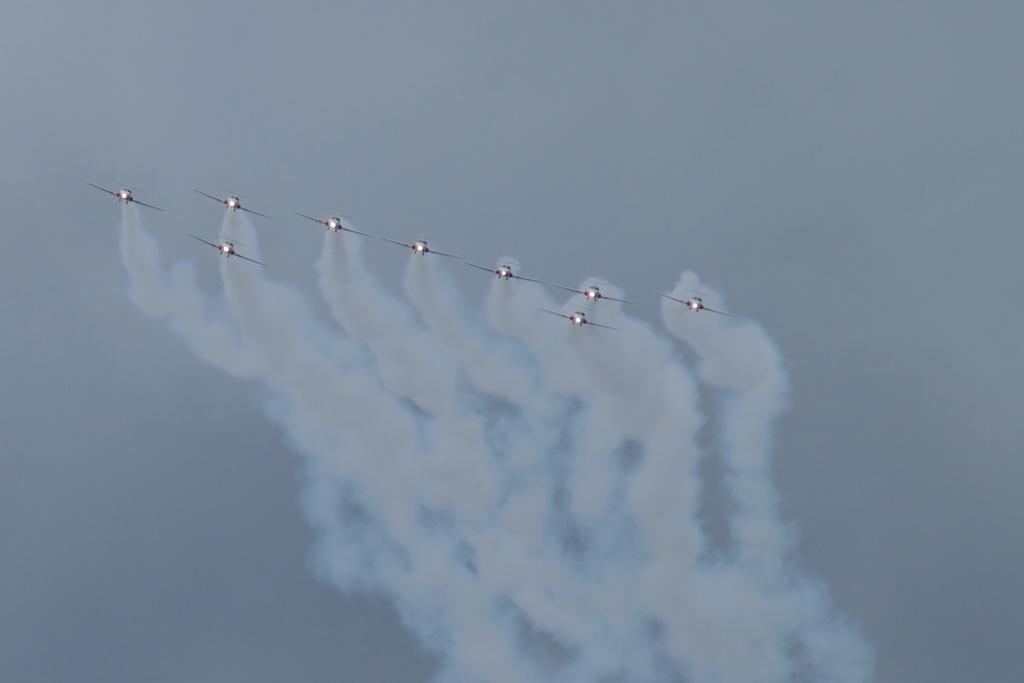What is the main subject of the image? The main subject of the image is aircrafts. Can you describe the appearance of the aircrafts? The aircrafts have fog coming out from them. What can be seen in the background of the image? The sky is visible in the background of the image. How many stitches are visible on the aircrafts in the image? There are no stitches visible on the aircrafts in the image. What type of cub can be seen playing with the aircrafts in the image? There is no cub present in the image; it features aircrafts with fog coming out from them. 